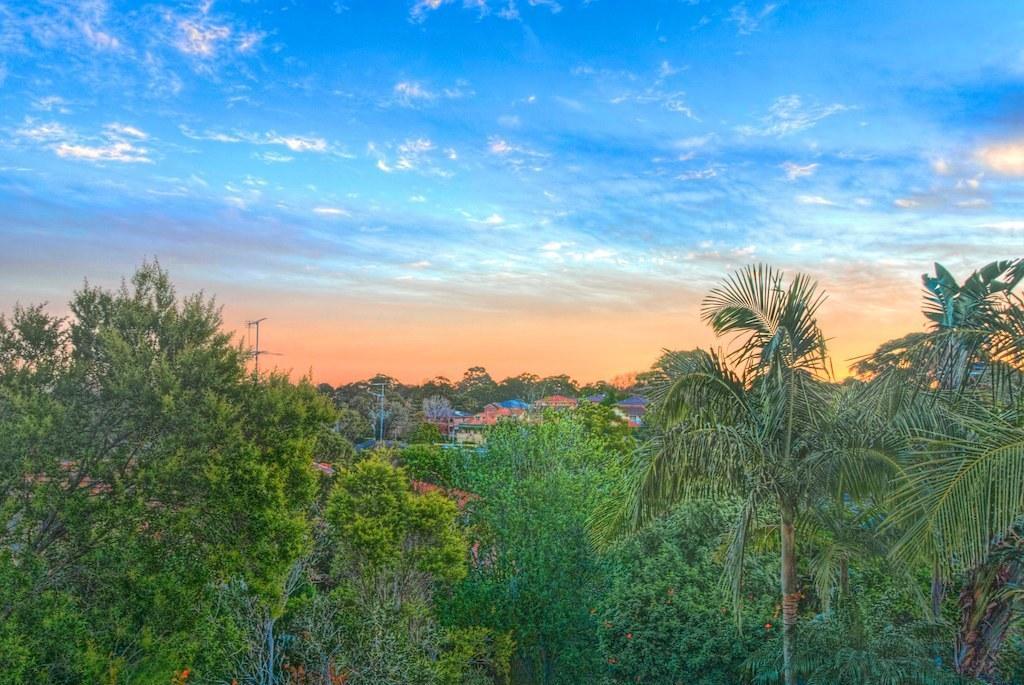In one or two sentences, can you explain what this image depicts? In this image at the bottom there are trees visible, in the middle there are poles, might be houses and trees visible, at the top there is the sky. 